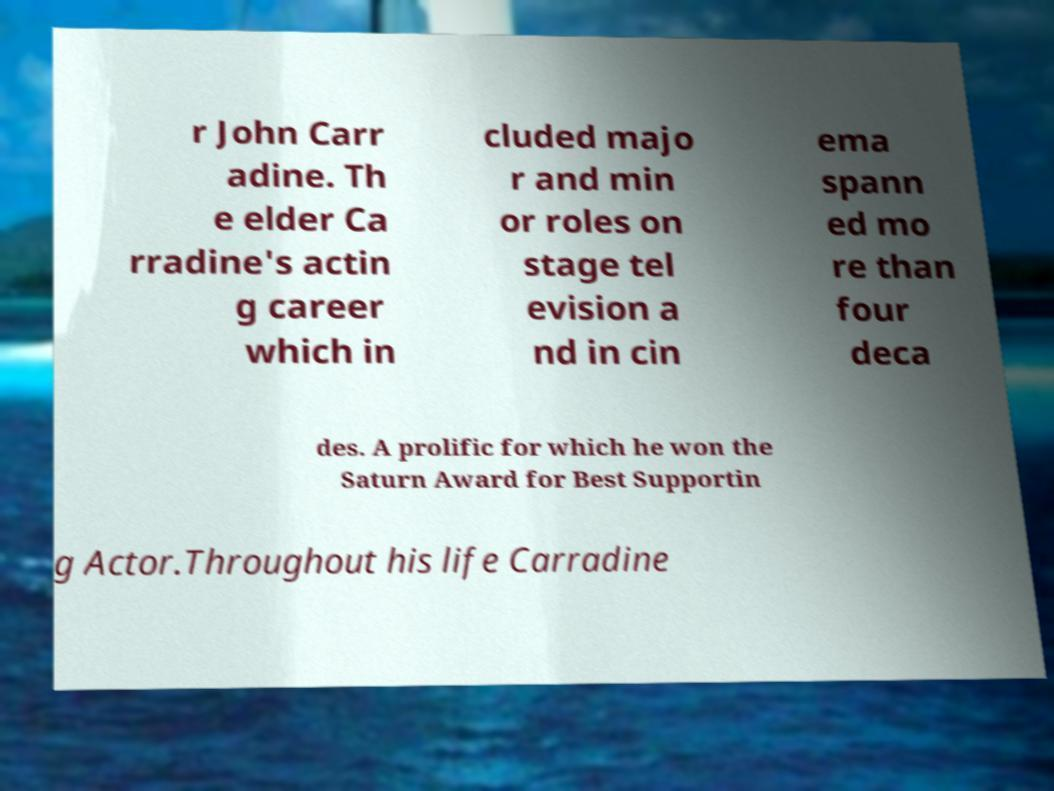What messages or text are displayed in this image? I need them in a readable, typed format. r John Carr adine. Th e elder Ca rradine's actin g career which in cluded majo r and min or roles on stage tel evision a nd in cin ema spann ed mo re than four deca des. A prolific for which he won the Saturn Award for Best Supportin g Actor.Throughout his life Carradine 